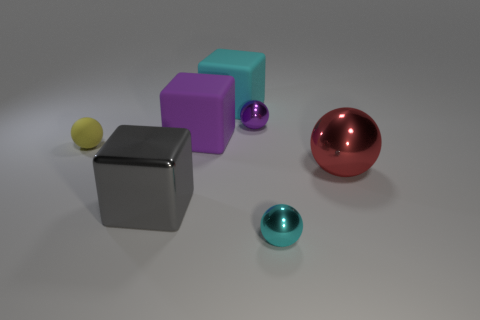Subtract all red balls. How many balls are left? 3 Subtract all gray blocks. How many blocks are left? 2 Add 3 green shiny things. How many objects exist? 10 Subtract all spheres. How many objects are left? 3 Subtract all brown cubes. Subtract all cyan balls. How many cubes are left? 3 Subtract all big brown matte things. Subtract all gray blocks. How many objects are left? 6 Add 1 large metallic things. How many large metallic things are left? 3 Add 4 small purple objects. How many small purple objects exist? 5 Subtract 0 yellow cylinders. How many objects are left? 7 Subtract 3 spheres. How many spheres are left? 1 